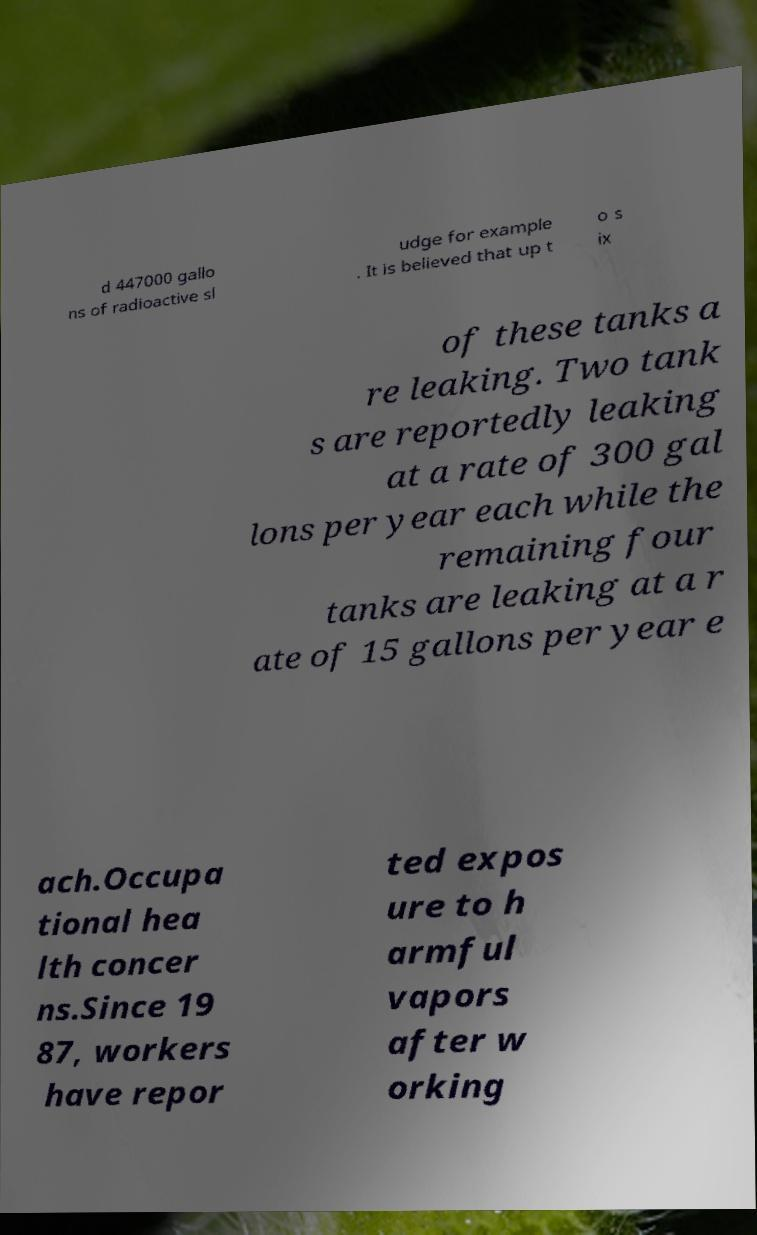Can you accurately transcribe the text from the provided image for me? d 447000 gallo ns of radioactive sl udge for example . It is believed that up t o s ix of these tanks a re leaking. Two tank s are reportedly leaking at a rate of 300 gal lons per year each while the remaining four tanks are leaking at a r ate of 15 gallons per year e ach.Occupa tional hea lth concer ns.Since 19 87, workers have repor ted expos ure to h armful vapors after w orking 